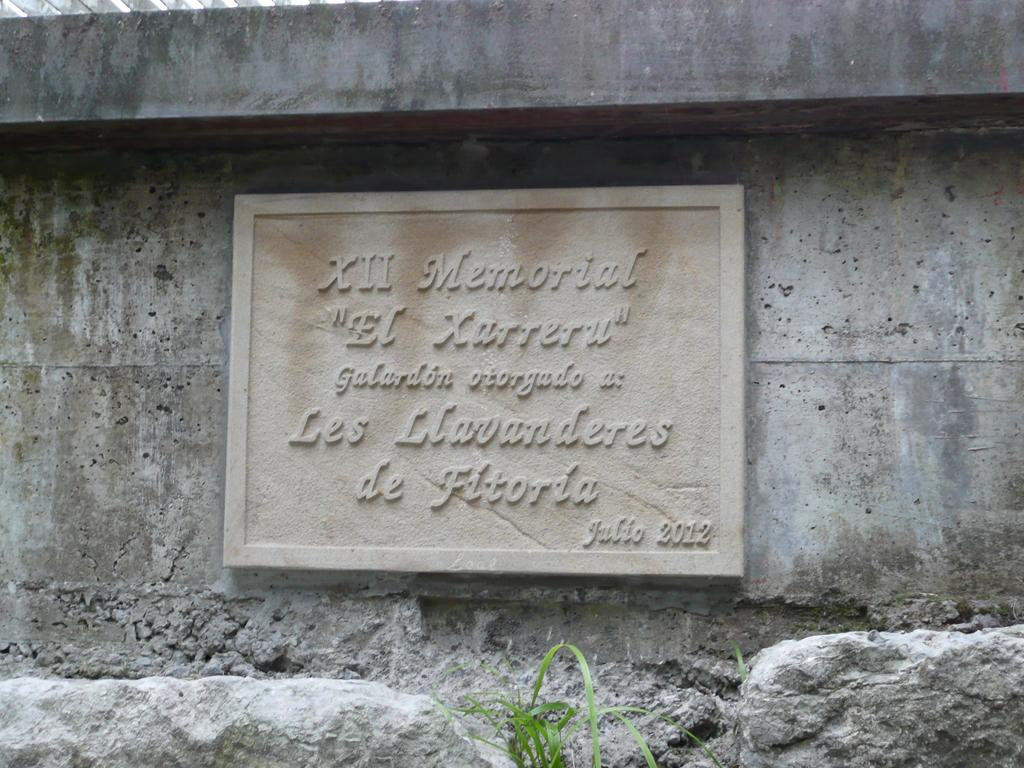What is attached to the wall in the image? There is a concrete board with text attached to the wall. What can be seen near the wall? There are two rocks near the wall. What type of vegetation is near the rocks? There is grass near the rocks. Can you describe the object on the top left side of the image? Unfortunately, the provided facts do not give any information about the object on the top left side of the image. How many cows are grazing in the grass near the rocks? There are no cows present in the image; it only features a concrete board with text, rocks, and grass. 